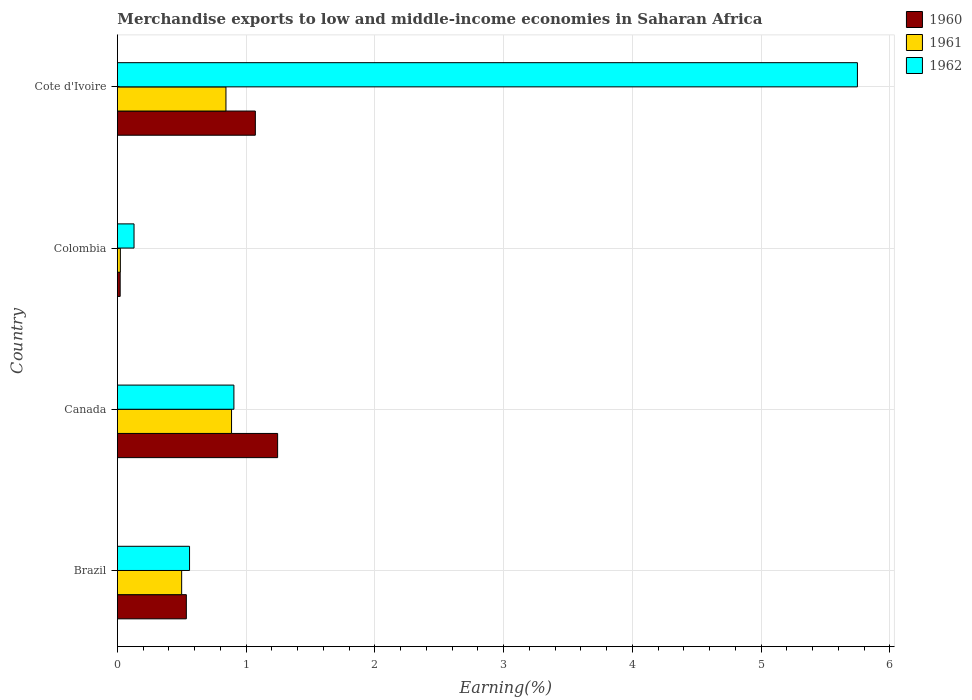How many groups of bars are there?
Offer a terse response. 4. Are the number of bars per tick equal to the number of legend labels?
Your answer should be compact. Yes. How many bars are there on the 2nd tick from the top?
Keep it short and to the point. 3. What is the label of the 3rd group of bars from the top?
Offer a terse response. Canada. In how many cases, is the number of bars for a given country not equal to the number of legend labels?
Make the answer very short. 0. What is the percentage of amount earned from merchandise exports in 1960 in Canada?
Keep it short and to the point. 1.24. Across all countries, what is the maximum percentage of amount earned from merchandise exports in 1960?
Keep it short and to the point. 1.24. Across all countries, what is the minimum percentage of amount earned from merchandise exports in 1960?
Give a very brief answer. 0.02. What is the total percentage of amount earned from merchandise exports in 1960 in the graph?
Offer a very short reply. 2.87. What is the difference between the percentage of amount earned from merchandise exports in 1962 in Canada and that in Colombia?
Offer a very short reply. 0.78. What is the difference between the percentage of amount earned from merchandise exports in 1961 in Brazil and the percentage of amount earned from merchandise exports in 1962 in Colombia?
Your answer should be very brief. 0.37. What is the average percentage of amount earned from merchandise exports in 1961 per country?
Ensure brevity in your answer.  0.56. What is the difference between the percentage of amount earned from merchandise exports in 1960 and percentage of amount earned from merchandise exports in 1961 in Cote d'Ivoire?
Give a very brief answer. 0.23. In how many countries, is the percentage of amount earned from merchandise exports in 1961 greater than 3.8 %?
Your response must be concise. 0. What is the ratio of the percentage of amount earned from merchandise exports in 1960 in Canada to that in Cote d'Ivoire?
Give a very brief answer. 1.16. What is the difference between the highest and the second highest percentage of amount earned from merchandise exports in 1962?
Keep it short and to the point. 4.84. What is the difference between the highest and the lowest percentage of amount earned from merchandise exports in 1962?
Give a very brief answer. 5.62. In how many countries, is the percentage of amount earned from merchandise exports in 1962 greater than the average percentage of amount earned from merchandise exports in 1962 taken over all countries?
Give a very brief answer. 1. Is the sum of the percentage of amount earned from merchandise exports in 1960 in Colombia and Cote d'Ivoire greater than the maximum percentage of amount earned from merchandise exports in 1961 across all countries?
Your answer should be compact. Yes. Is it the case that in every country, the sum of the percentage of amount earned from merchandise exports in 1961 and percentage of amount earned from merchandise exports in 1960 is greater than the percentage of amount earned from merchandise exports in 1962?
Give a very brief answer. No. How many countries are there in the graph?
Provide a succinct answer. 4. Does the graph contain grids?
Offer a very short reply. Yes. Where does the legend appear in the graph?
Give a very brief answer. Top right. What is the title of the graph?
Your answer should be compact. Merchandise exports to low and middle-income economies in Saharan Africa. Does "2006" appear as one of the legend labels in the graph?
Your response must be concise. No. What is the label or title of the X-axis?
Offer a very short reply. Earning(%). What is the label or title of the Y-axis?
Offer a terse response. Country. What is the Earning(%) in 1960 in Brazil?
Keep it short and to the point. 0.54. What is the Earning(%) of 1961 in Brazil?
Make the answer very short. 0.5. What is the Earning(%) in 1962 in Brazil?
Your response must be concise. 0.56. What is the Earning(%) of 1960 in Canada?
Make the answer very short. 1.24. What is the Earning(%) of 1961 in Canada?
Make the answer very short. 0.89. What is the Earning(%) of 1962 in Canada?
Your answer should be compact. 0.9. What is the Earning(%) in 1960 in Colombia?
Your answer should be very brief. 0.02. What is the Earning(%) in 1961 in Colombia?
Provide a short and direct response. 0.02. What is the Earning(%) in 1962 in Colombia?
Your response must be concise. 0.13. What is the Earning(%) in 1960 in Cote d'Ivoire?
Provide a short and direct response. 1.07. What is the Earning(%) in 1961 in Cote d'Ivoire?
Your answer should be compact. 0.84. What is the Earning(%) of 1962 in Cote d'Ivoire?
Your answer should be very brief. 5.75. Across all countries, what is the maximum Earning(%) of 1960?
Your answer should be very brief. 1.24. Across all countries, what is the maximum Earning(%) in 1961?
Your answer should be compact. 0.89. Across all countries, what is the maximum Earning(%) of 1962?
Your answer should be compact. 5.75. Across all countries, what is the minimum Earning(%) of 1960?
Your response must be concise. 0.02. Across all countries, what is the minimum Earning(%) in 1961?
Offer a terse response. 0.02. Across all countries, what is the minimum Earning(%) of 1962?
Your answer should be very brief. 0.13. What is the total Earning(%) of 1960 in the graph?
Ensure brevity in your answer.  2.87. What is the total Earning(%) of 1961 in the graph?
Keep it short and to the point. 2.25. What is the total Earning(%) in 1962 in the graph?
Provide a succinct answer. 7.34. What is the difference between the Earning(%) in 1960 in Brazil and that in Canada?
Your answer should be very brief. -0.71. What is the difference between the Earning(%) of 1961 in Brazil and that in Canada?
Give a very brief answer. -0.39. What is the difference between the Earning(%) of 1962 in Brazil and that in Canada?
Keep it short and to the point. -0.34. What is the difference between the Earning(%) of 1960 in Brazil and that in Colombia?
Offer a very short reply. 0.51. What is the difference between the Earning(%) of 1961 in Brazil and that in Colombia?
Provide a succinct answer. 0.48. What is the difference between the Earning(%) in 1962 in Brazil and that in Colombia?
Give a very brief answer. 0.43. What is the difference between the Earning(%) in 1960 in Brazil and that in Cote d'Ivoire?
Ensure brevity in your answer.  -0.54. What is the difference between the Earning(%) in 1961 in Brazil and that in Cote d'Ivoire?
Offer a very short reply. -0.34. What is the difference between the Earning(%) in 1962 in Brazil and that in Cote d'Ivoire?
Provide a succinct answer. -5.19. What is the difference between the Earning(%) in 1960 in Canada and that in Colombia?
Provide a succinct answer. 1.22. What is the difference between the Earning(%) of 1961 in Canada and that in Colombia?
Ensure brevity in your answer.  0.86. What is the difference between the Earning(%) of 1962 in Canada and that in Colombia?
Keep it short and to the point. 0.78. What is the difference between the Earning(%) of 1960 in Canada and that in Cote d'Ivoire?
Offer a very short reply. 0.17. What is the difference between the Earning(%) of 1961 in Canada and that in Cote d'Ivoire?
Make the answer very short. 0.04. What is the difference between the Earning(%) of 1962 in Canada and that in Cote d'Ivoire?
Your answer should be very brief. -4.84. What is the difference between the Earning(%) of 1960 in Colombia and that in Cote d'Ivoire?
Your response must be concise. -1.05. What is the difference between the Earning(%) in 1961 in Colombia and that in Cote d'Ivoire?
Your answer should be very brief. -0.82. What is the difference between the Earning(%) in 1962 in Colombia and that in Cote d'Ivoire?
Offer a terse response. -5.62. What is the difference between the Earning(%) of 1960 in Brazil and the Earning(%) of 1961 in Canada?
Your answer should be very brief. -0.35. What is the difference between the Earning(%) of 1960 in Brazil and the Earning(%) of 1962 in Canada?
Provide a succinct answer. -0.37. What is the difference between the Earning(%) in 1961 in Brazil and the Earning(%) in 1962 in Canada?
Keep it short and to the point. -0.41. What is the difference between the Earning(%) in 1960 in Brazil and the Earning(%) in 1961 in Colombia?
Provide a succinct answer. 0.51. What is the difference between the Earning(%) in 1960 in Brazil and the Earning(%) in 1962 in Colombia?
Offer a very short reply. 0.41. What is the difference between the Earning(%) of 1961 in Brazil and the Earning(%) of 1962 in Colombia?
Give a very brief answer. 0.37. What is the difference between the Earning(%) in 1960 in Brazil and the Earning(%) in 1961 in Cote d'Ivoire?
Make the answer very short. -0.31. What is the difference between the Earning(%) of 1960 in Brazil and the Earning(%) of 1962 in Cote d'Ivoire?
Make the answer very short. -5.21. What is the difference between the Earning(%) in 1961 in Brazil and the Earning(%) in 1962 in Cote d'Ivoire?
Provide a short and direct response. -5.25. What is the difference between the Earning(%) of 1960 in Canada and the Earning(%) of 1961 in Colombia?
Provide a succinct answer. 1.22. What is the difference between the Earning(%) of 1960 in Canada and the Earning(%) of 1962 in Colombia?
Provide a short and direct response. 1.12. What is the difference between the Earning(%) in 1961 in Canada and the Earning(%) in 1962 in Colombia?
Keep it short and to the point. 0.76. What is the difference between the Earning(%) in 1960 in Canada and the Earning(%) in 1961 in Cote d'Ivoire?
Provide a short and direct response. 0.4. What is the difference between the Earning(%) in 1960 in Canada and the Earning(%) in 1962 in Cote d'Ivoire?
Offer a very short reply. -4.5. What is the difference between the Earning(%) of 1961 in Canada and the Earning(%) of 1962 in Cote d'Ivoire?
Your response must be concise. -4.86. What is the difference between the Earning(%) in 1960 in Colombia and the Earning(%) in 1961 in Cote d'Ivoire?
Your answer should be compact. -0.82. What is the difference between the Earning(%) in 1960 in Colombia and the Earning(%) in 1962 in Cote d'Ivoire?
Ensure brevity in your answer.  -5.73. What is the difference between the Earning(%) in 1961 in Colombia and the Earning(%) in 1962 in Cote d'Ivoire?
Your response must be concise. -5.73. What is the average Earning(%) in 1960 per country?
Offer a very short reply. 0.72. What is the average Earning(%) in 1961 per country?
Your answer should be very brief. 0.56. What is the average Earning(%) of 1962 per country?
Make the answer very short. 1.84. What is the difference between the Earning(%) in 1960 and Earning(%) in 1961 in Brazil?
Your answer should be very brief. 0.04. What is the difference between the Earning(%) of 1960 and Earning(%) of 1962 in Brazil?
Your answer should be compact. -0.02. What is the difference between the Earning(%) of 1961 and Earning(%) of 1962 in Brazil?
Your answer should be very brief. -0.06. What is the difference between the Earning(%) in 1960 and Earning(%) in 1961 in Canada?
Offer a very short reply. 0.36. What is the difference between the Earning(%) of 1960 and Earning(%) of 1962 in Canada?
Keep it short and to the point. 0.34. What is the difference between the Earning(%) in 1961 and Earning(%) in 1962 in Canada?
Your answer should be compact. -0.02. What is the difference between the Earning(%) of 1960 and Earning(%) of 1961 in Colombia?
Offer a terse response. -0. What is the difference between the Earning(%) of 1960 and Earning(%) of 1962 in Colombia?
Offer a terse response. -0.11. What is the difference between the Earning(%) of 1961 and Earning(%) of 1962 in Colombia?
Ensure brevity in your answer.  -0.11. What is the difference between the Earning(%) of 1960 and Earning(%) of 1961 in Cote d'Ivoire?
Ensure brevity in your answer.  0.23. What is the difference between the Earning(%) of 1960 and Earning(%) of 1962 in Cote d'Ivoire?
Your response must be concise. -4.68. What is the difference between the Earning(%) of 1961 and Earning(%) of 1962 in Cote d'Ivoire?
Offer a terse response. -4.91. What is the ratio of the Earning(%) of 1960 in Brazil to that in Canada?
Make the answer very short. 0.43. What is the ratio of the Earning(%) of 1961 in Brazil to that in Canada?
Provide a succinct answer. 0.56. What is the ratio of the Earning(%) in 1962 in Brazil to that in Canada?
Give a very brief answer. 0.62. What is the ratio of the Earning(%) in 1960 in Brazil to that in Colombia?
Keep it short and to the point. 24.92. What is the ratio of the Earning(%) of 1961 in Brazil to that in Colombia?
Give a very brief answer. 21.72. What is the ratio of the Earning(%) in 1962 in Brazil to that in Colombia?
Keep it short and to the point. 4.34. What is the ratio of the Earning(%) of 1960 in Brazil to that in Cote d'Ivoire?
Give a very brief answer. 0.5. What is the ratio of the Earning(%) in 1961 in Brazil to that in Cote d'Ivoire?
Offer a very short reply. 0.59. What is the ratio of the Earning(%) in 1962 in Brazil to that in Cote d'Ivoire?
Provide a short and direct response. 0.1. What is the ratio of the Earning(%) of 1960 in Canada to that in Colombia?
Your answer should be very brief. 57.92. What is the ratio of the Earning(%) of 1961 in Canada to that in Colombia?
Keep it short and to the point. 38.58. What is the ratio of the Earning(%) of 1962 in Canada to that in Colombia?
Ensure brevity in your answer.  7.01. What is the ratio of the Earning(%) in 1960 in Canada to that in Cote d'Ivoire?
Keep it short and to the point. 1.16. What is the ratio of the Earning(%) in 1961 in Canada to that in Cote d'Ivoire?
Offer a very short reply. 1.05. What is the ratio of the Earning(%) of 1962 in Canada to that in Cote d'Ivoire?
Your response must be concise. 0.16. What is the ratio of the Earning(%) in 1960 in Colombia to that in Cote d'Ivoire?
Your answer should be compact. 0.02. What is the ratio of the Earning(%) of 1961 in Colombia to that in Cote d'Ivoire?
Your answer should be very brief. 0.03. What is the ratio of the Earning(%) of 1962 in Colombia to that in Cote d'Ivoire?
Give a very brief answer. 0.02. What is the difference between the highest and the second highest Earning(%) of 1960?
Give a very brief answer. 0.17. What is the difference between the highest and the second highest Earning(%) in 1961?
Keep it short and to the point. 0.04. What is the difference between the highest and the second highest Earning(%) in 1962?
Provide a succinct answer. 4.84. What is the difference between the highest and the lowest Earning(%) of 1960?
Provide a short and direct response. 1.22. What is the difference between the highest and the lowest Earning(%) of 1961?
Your answer should be compact. 0.86. What is the difference between the highest and the lowest Earning(%) of 1962?
Provide a succinct answer. 5.62. 